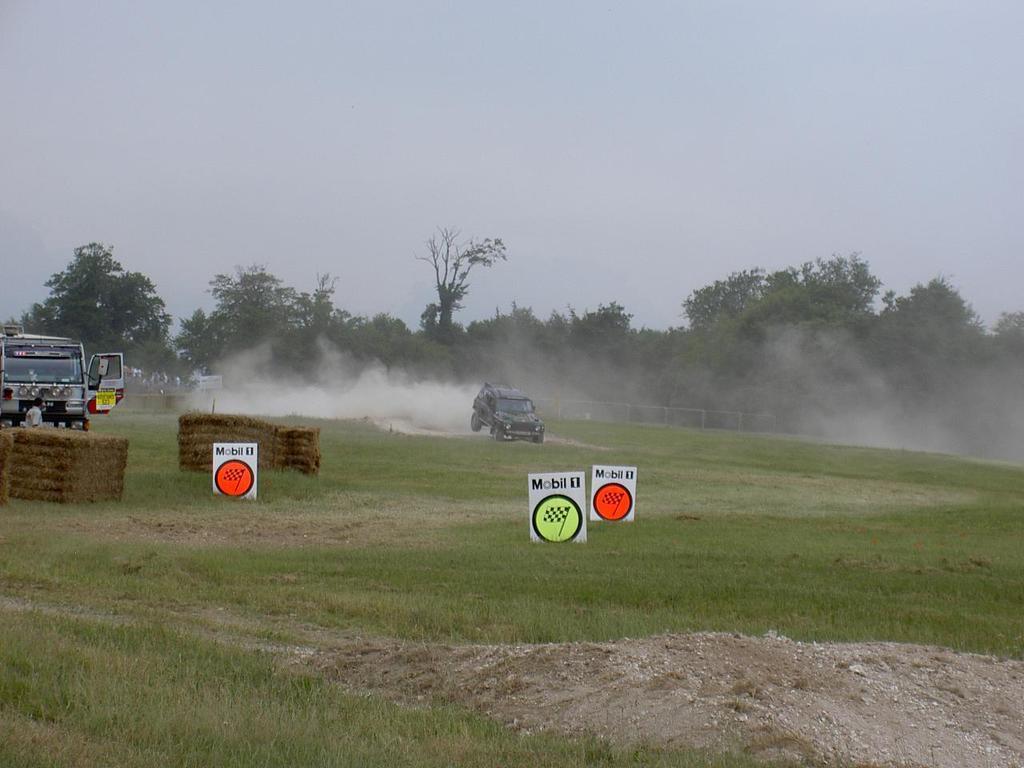Please provide a concise description of this image. In this picture there is a person and we can see dried grass, vehicles on the grass, boards and smoke. In the background of the image we can see fence, trees and sky. 